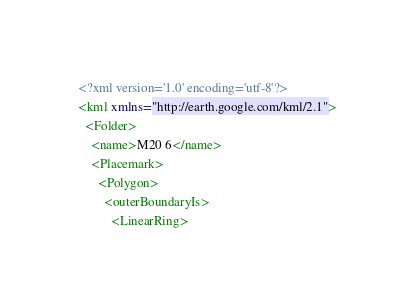Convert code to text. <code><loc_0><loc_0><loc_500><loc_500><_XML_><?xml version='1.0' encoding='utf-8'?>
<kml xmlns="http://earth.google.com/kml/2.1">
  <Folder>
    <name>M20 6</name>
    <Placemark>
      <Polygon>
        <outerBoundaryIs>
          <LinearRing></code> 